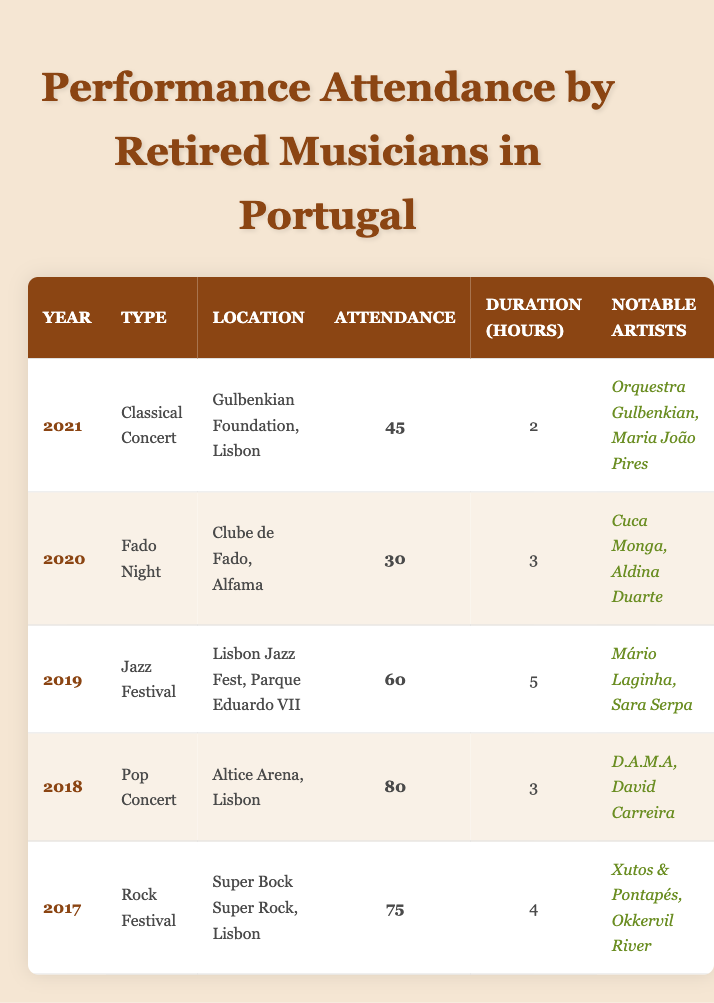What type of performance had the highest attendance? Looking at the attendance column, the Pop Concert in 2018 had the highest attendance with 80 attendees.
Answer: Pop Concert How many performances were held in Lisbon? By examining the locations, I find that all five performances are held in Lisbon, indicated by their respective venues.
Answer: 5 What was the average duration of the performances? The durations are 2, 3, 5, 3, and 4 hours. Calculating the average: (2 + 3 + 5 + 3 + 4) / 5 = 17 / 5 = 3.4 hours.
Answer: 3.4 hours Did any performances feature the artist Aldina Duarte? According to the notable artists listed, Aldina Duarte performed at the Fado Night in 2020. Therefore, the answer is yes.
Answer: Yes Which performance took place in 2019 and how long did it last? In 2019, the Jazz Festival occurred, with a duration of 5 hours as noted in the table.
Answer: Jazz Festival, 5 hours What type of performance had the lowest attendance? The attendance records reveal that the Fado Night in 2020 had the lowest attendance, with only 30 attendees.
Answer: Fado Night How many performances lasted longer than three hours? The performances with durations longer than three hours are the Jazz Festival (5 hours) and Rock Festival (4 hours), totaling two performances.
Answer: 2 Was the Classical Concert held at Gulbenkian Foundation? The table indicates that the Classical Concert in 2021 indeed took place at the Gulbenkian Foundation. Therefore, the answer is yes.
Answer: Yes How many different types of performances are listed in the table? The types of performances listed are Classical Concert, Fado Night, Jazz Festival, Pop Concert, and Rock Festival. This counts as five distinct types.
Answer: 5 